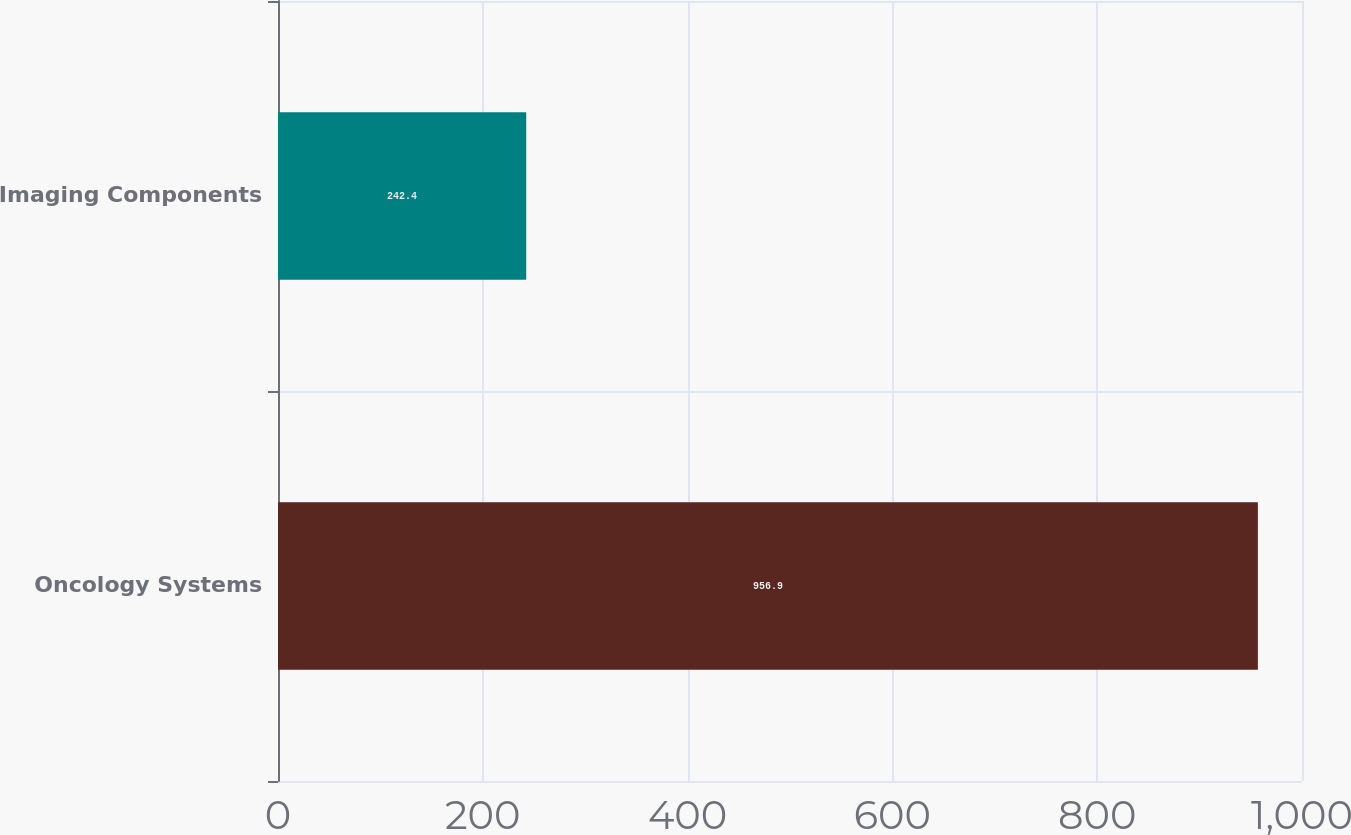<chart> <loc_0><loc_0><loc_500><loc_500><bar_chart><fcel>Oncology Systems<fcel>Imaging Components<nl><fcel>956.9<fcel>242.4<nl></chart> 